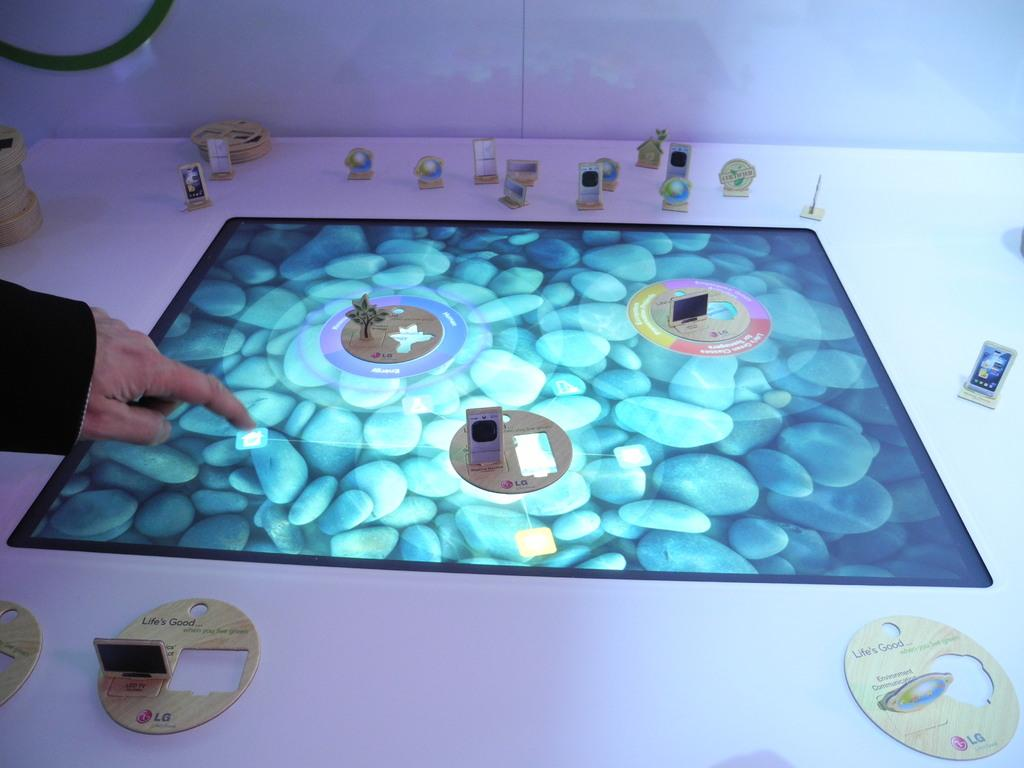What is the main subject in the center of the image? There is a screen in the center of the image. What can be seen on the screen? Objects are visible on the screen. Where is the hand of a person located in the image? The hand of a person is on the left side of the image. What is visible in the background of the image? There are objects on a table in the background of the image. What type of fruit is being caught by the net in the image? There is no fruit or net present in the image. What animal can be seen interacting with the objects on the screen? There are no animals visible in the image; only a hand and objects on the screen are present. 